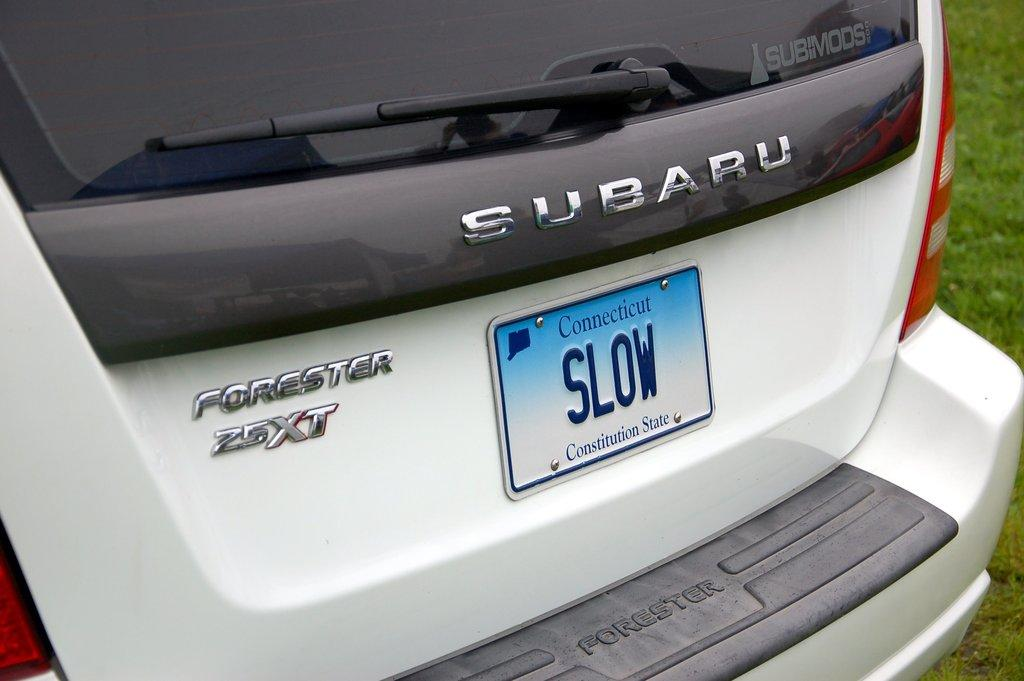<image>
Offer a succinct explanation of the picture presented. White Subaru van with a license plate that says "SLOW". 